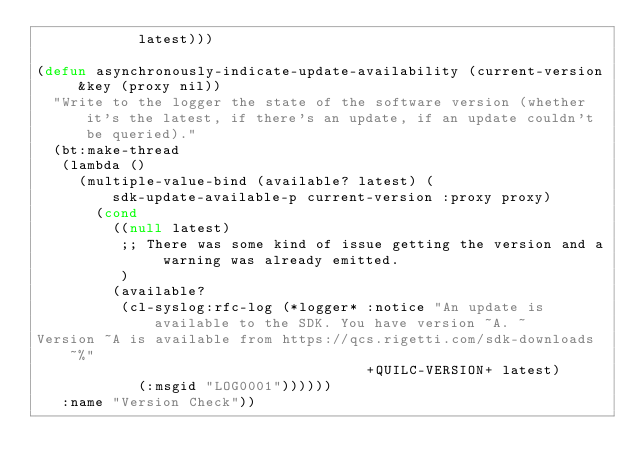<code> <loc_0><loc_0><loc_500><loc_500><_Lisp_>            latest)))

(defun asynchronously-indicate-update-availability (current-version &key (proxy nil))
  "Write to the logger the state of the software version (whether it's the latest, if there's an update, if an update couldn't be queried)."
  (bt:make-thread
   (lambda ()
     (multiple-value-bind (available? latest) (sdk-update-available-p current-version :proxy proxy)
       (cond
         ((null latest)
          ;; There was some kind of issue getting the version and a warning was already emitted.
          )
         (available?
          (cl-syslog:rfc-log (*logger* :notice "An update is available to the SDK. You have version ~A. ~
Version ~A is available from https://qcs.rigetti.com/sdk-downloads~%"
                                       +QUILC-VERSION+ latest)
            (:msgid "LOG0001"))))))
   :name "Version Check"))
</code> 